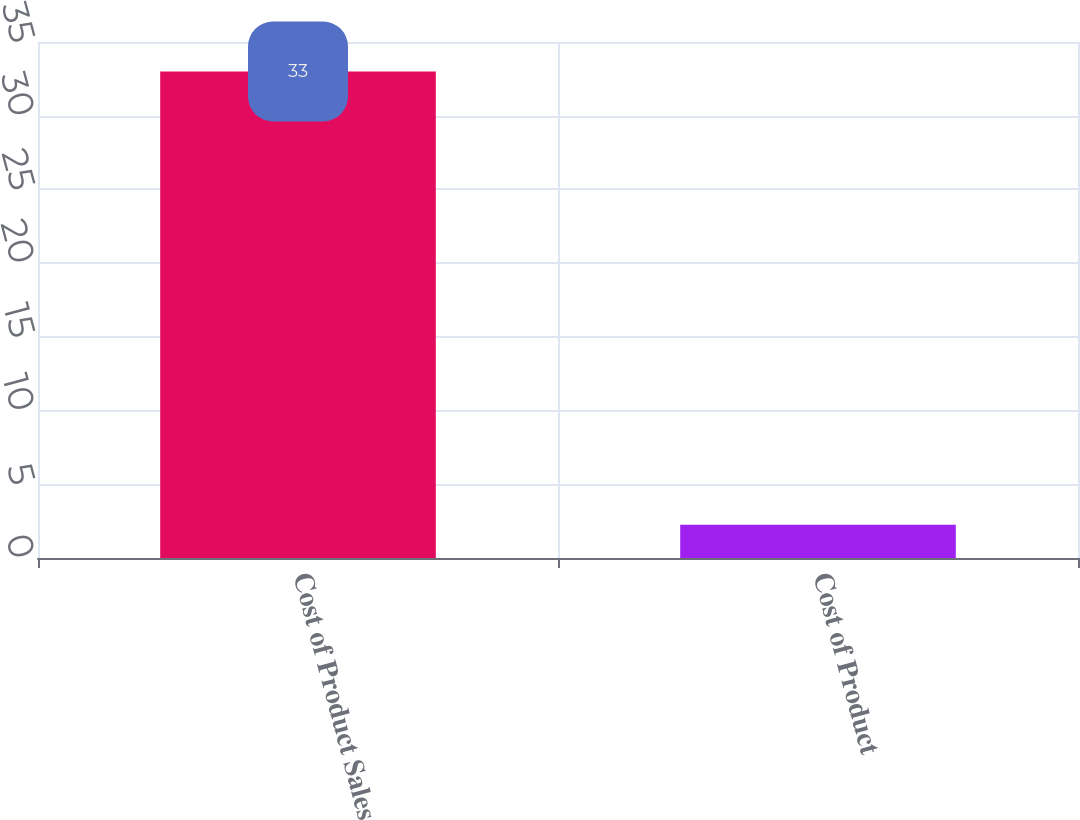<chart> <loc_0><loc_0><loc_500><loc_500><bar_chart><fcel>Cost of Product Sales<fcel>Cost of Product<nl><fcel>33<fcel>2.25<nl></chart> 